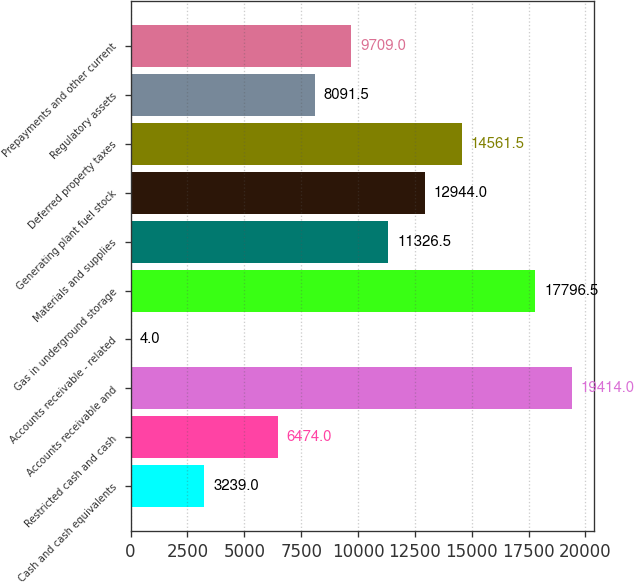Convert chart to OTSL. <chart><loc_0><loc_0><loc_500><loc_500><bar_chart><fcel>Cash and cash equivalents<fcel>Restricted cash and cash<fcel>Accounts receivable and<fcel>Accounts receivable - related<fcel>Gas in underground storage<fcel>Materials and supplies<fcel>Generating plant fuel stock<fcel>Deferred property taxes<fcel>Regulatory assets<fcel>Prepayments and other current<nl><fcel>3239<fcel>6474<fcel>19414<fcel>4<fcel>17796.5<fcel>11326.5<fcel>12944<fcel>14561.5<fcel>8091.5<fcel>9709<nl></chart> 